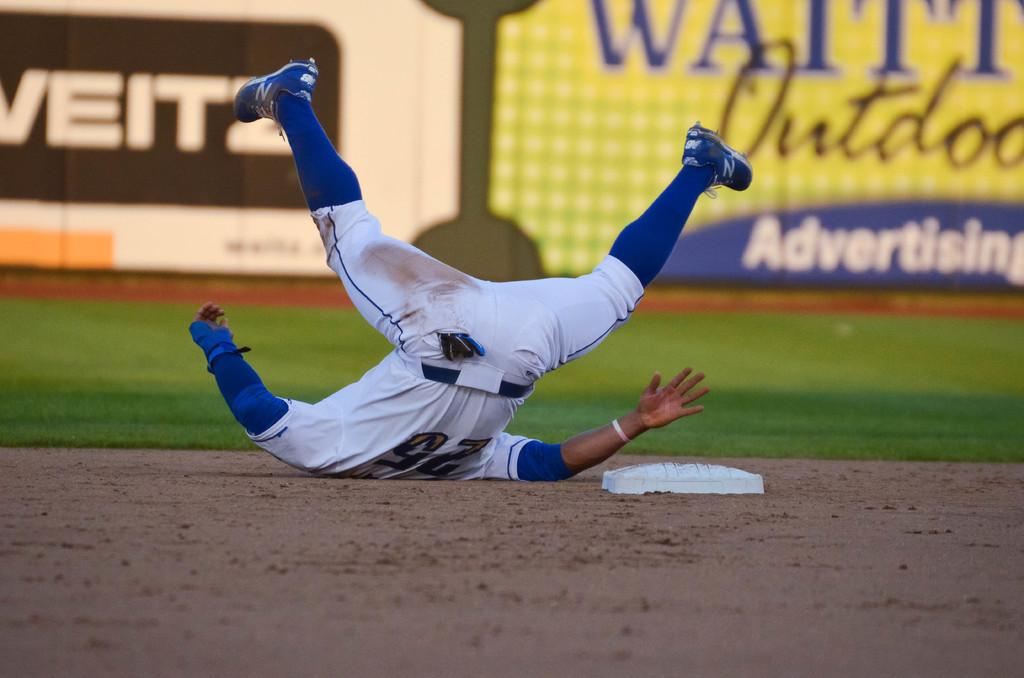Provide a one-sentence caption for the provided image. The number 25 player falls to the ground. 